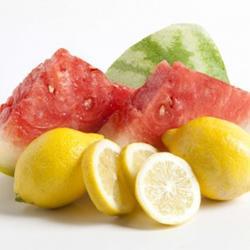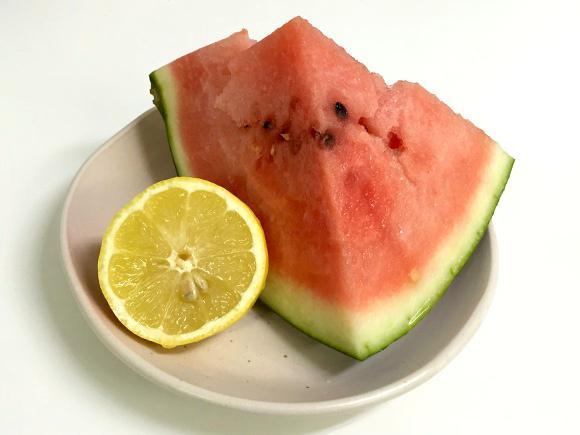The first image is the image on the left, the second image is the image on the right. For the images displayed, is the sentence "The liquid in the glass is pink and garnished with fruit." factually correct? Answer yes or no. No. The first image is the image on the left, the second image is the image on the right. For the images shown, is this caption "At least one small pink drink with a garnish of lemon or watermelon is seen in each image." true? Answer yes or no. No. 